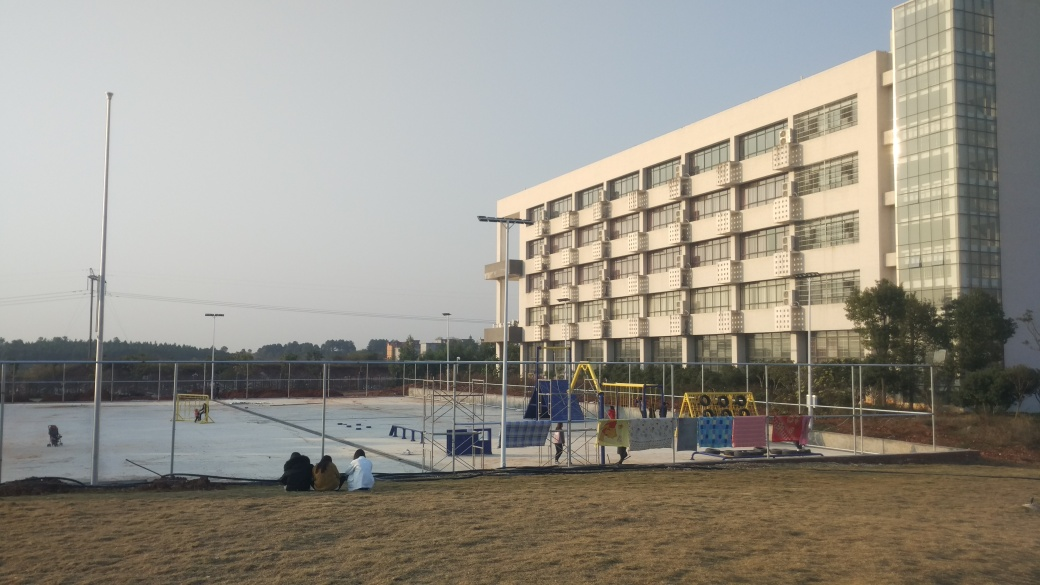What is the quality of the image?
A. mediocre
B. bad
C. good The quality of the image is good. It is well-lit with clear details, properly exposed with no apparent blurring, and the composition is balanced, providing a good representation of the scene. 